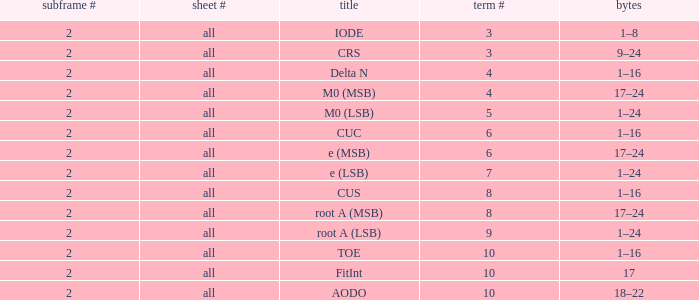What is the average word count with crs and subframes lesser than 2? None. 